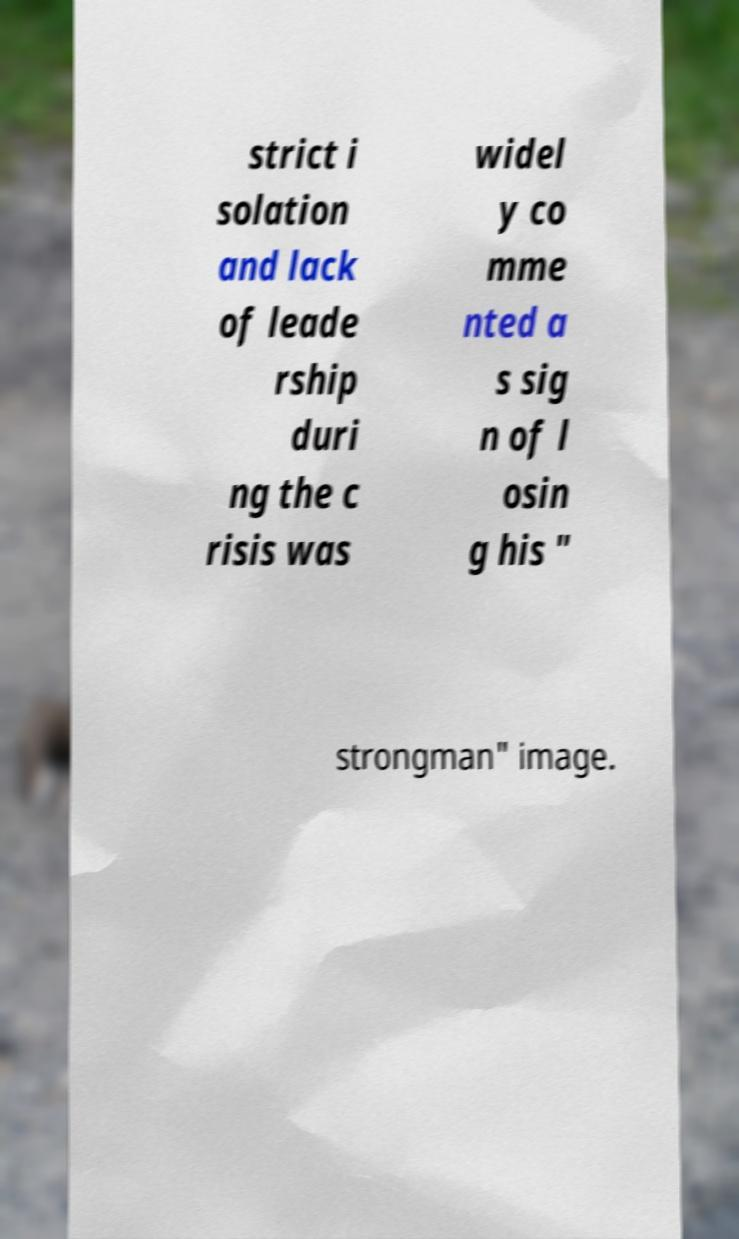Could you assist in decoding the text presented in this image and type it out clearly? strict i solation and lack of leade rship duri ng the c risis was widel y co mme nted a s sig n of l osin g his " strongman" image. 